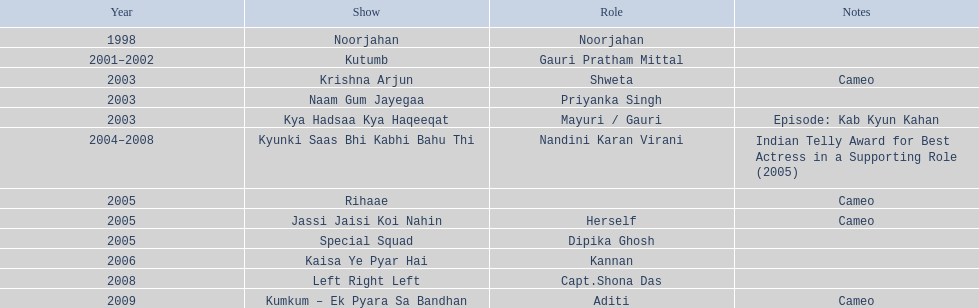What function did gauri pradhan tejwani serve in 1998? Noorjahan. In which tv series did gauri make a brief appearance in 2003? Krishna Arjun. In which television show was gauri involved for the longest time? Kyunki Saas Bhi Kabhi Bahu Thi. 